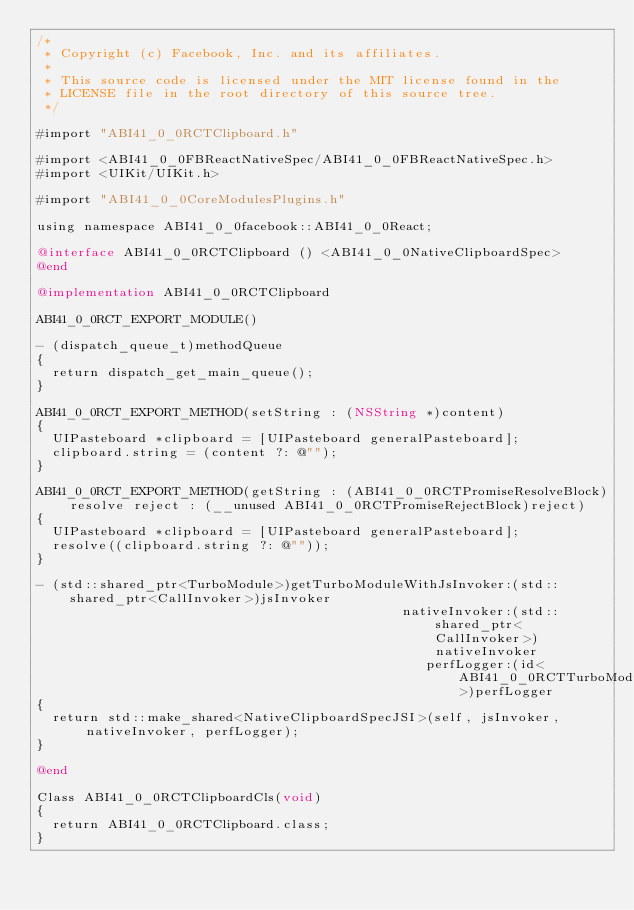<code> <loc_0><loc_0><loc_500><loc_500><_ObjectiveC_>/*
 * Copyright (c) Facebook, Inc. and its affiliates.
 *
 * This source code is licensed under the MIT license found in the
 * LICENSE file in the root directory of this source tree.
 */

#import "ABI41_0_0RCTClipboard.h"

#import <ABI41_0_0FBReactNativeSpec/ABI41_0_0FBReactNativeSpec.h>
#import <UIKit/UIKit.h>

#import "ABI41_0_0CoreModulesPlugins.h"

using namespace ABI41_0_0facebook::ABI41_0_0React;

@interface ABI41_0_0RCTClipboard () <ABI41_0_0NativeClipboardSpec>
@end

@implementation ABI41_0_0RCTClipboard

ABI41_0_0RCT_EXPORT_MODULE()

- (dispatch_queue_t)methodQueue
{
  return dispatch_get_main_queue();
}

ABI41_0_0RCT_EXPORT_METHOD(setString : (NSString *)content)
{
  UIPasteboard *clipboard = [UIPasteboard generalPasteboard];
  clipboard.string = (content ?: @"");
}

ABI41_0_0RCT_EXPORT_METHOD(getString : (ABI41_0_0RCTPromiseResolveBlock)resolve reject : (__unused ABI41_0_0RCTPromiseRejectBlock)reject)
{
  UIPasteboard *clipboard = [UIPasteboard generalPasteboard];
  resolve((clipboard.string ?: @""));
}

- (std::shared_ptr<TurboModule>)getTurboModuleWithJsInvoker:(std::shared_ptr<CallInvoker>)jsInvoker
                                              nativeInvoker:(std::shared_ptr<CallInvoker>)nativeInvoker
                                                 perfLogger:(id<ABI41_0_0RCTTurboModulePerformanceLogger>)perfLogger
{
  return std::make_shared<NativeClipboardSpecJSI>(self, jsInvoker, nativeInvoker, perfLogger);
}

@end

Class ABI41_0_0RCTClipboardCls(void)
{
  return ABI41_0_0RCTClipboard.class;
}
</code> 